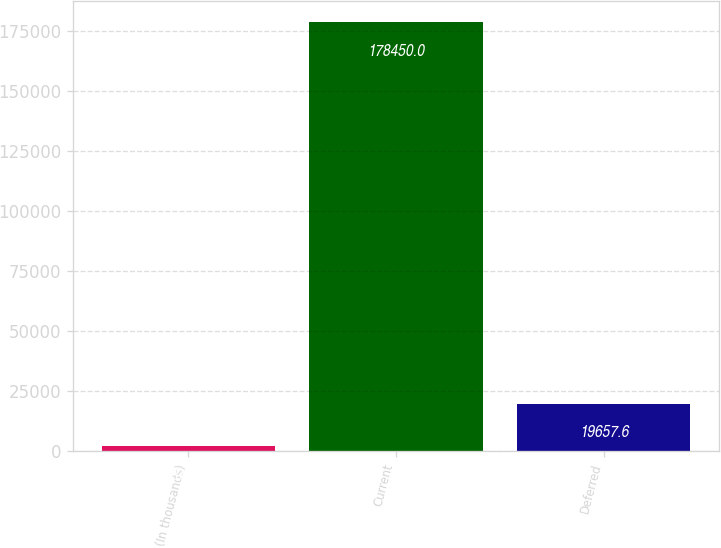Convert chart to OTSL. <chart><loc_0><loc_0><loc_500><loc_500><bar_chart><fcel>(In thousands)<fcel>Current<fcel>Deferred<nl><fcel>2014<fcel>178450<fcel>19657.6<nl></chart> 